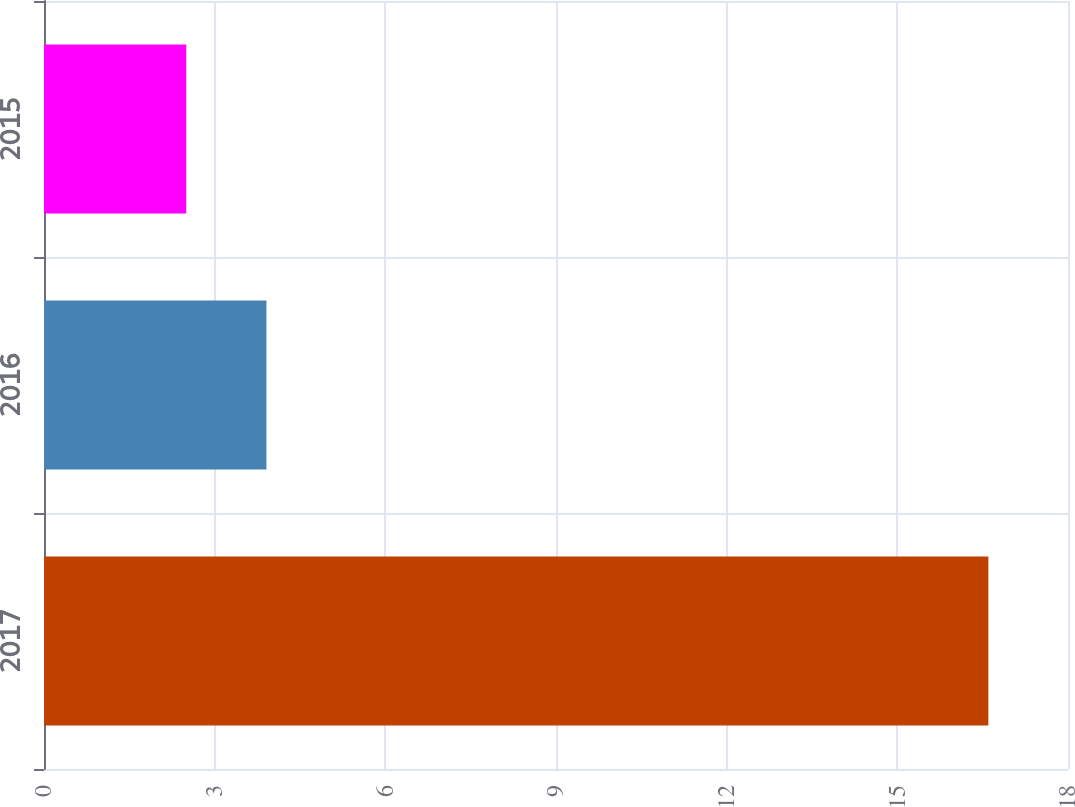Convert chart to OTSL. <chart><loc_0><loc_0><loc_500><loc_500><bar_chart><fcel>2017<fcel>2016<fcel>2015<nl><fcel>16.6<fcel>3.91<fcel>2.5<nl></chart> 